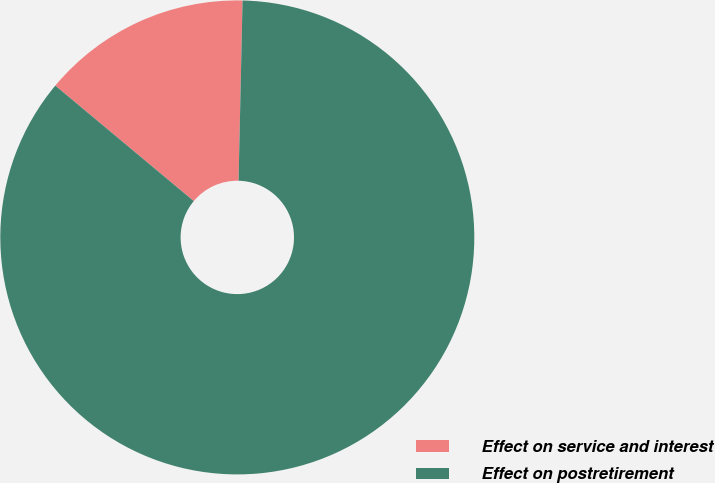Convert chart to OTSL. <chart><loc_0><loc_0><loc_500><loc_500><pie_chart><fcel>Effect on service and interest<fcel>Effect on postretirement<nl><fcel>14.29%<fcel>85.71%<nl></chart> 